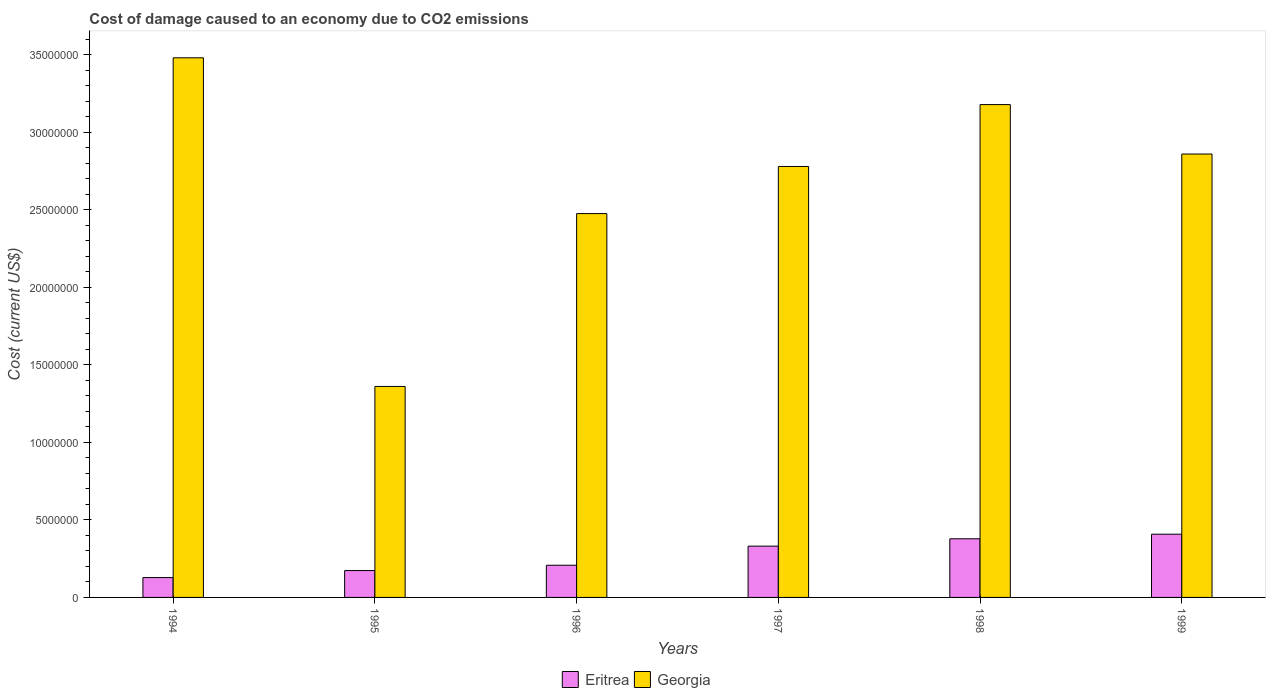How many different coloured bars are there?
Make the answer very short. 2. How many groups of bars are there?
Give a very brief answer. 6. Are the number of bars on each tick of the X-axis equal?
Your answer should be compact. Yes. How many bars are there on the 5th tick from the left?
Make the answer very short. 2. How many bars are there on the 6th tick from the right?
Give a very brief answer. 2. What is the label of the 1st group of bars from the left?
Keep it short and to the point. 1994. What is the cost of damage caused due to CO2 emissisons in Georgia in 1995?
Offer a terse response. 1.36e+07. Across all years, what is the maximum cost of damage caused due to CO2 emissisons in Georgia?
Offer a terse response. 3.48e+07. Across all years, what is the minimum cost of damage caused due to CO2 emissisons in Eritrea?
Ensure brevity in your answer.  1.28e+06. In which year was the cost of damage caused due to CO2 emissisons in Georgia minimum?
Offer a very short reply. 1995. What is the total cost of damage caused due to CO2 emissisons in Georgia in the graph?
Your response must be concise. 1.61e+08. What is the difference between the cost of damage caused due to CO2 emissisons in Georgia in 1996 and that in 1999?
Make the answer very short. -3.84e+06. What is the difference between the cost of damage caused due to CO2 emissisons in Eritrea in 1996 and the cost of damage caused due to CO2 emissisons in Georgia in 1999?
Provide a short and direct response. -2.65e+07. What is the average cost of damage caused due to CO2 emissisons in Eritrea per year?
Make the answer very short. 2.71e+06. In the year 1996, what is the difference between the cost of damage caused due to CO2 emissisons in Georgia and cost of damage caused due to CO2 emissisons in Eritrea?
Give a very brief answer. 2.27e+07. What is the ratio of the cost of damage caused due to CO2 emissisons in Eritrea in 1994 to that in 1999?
Your answer should be very brief. 0.31. Is the difference between the cost of damage caused due to CO2 emissisons in Georgia in 1994 and 1996 greater than the difference between the cost of damage caused due to CO2 emissisons in Eritrea in 1994 and 1996?
Offer a very short reply. Yes. What is the difference between the highest and the second highest cost of damage caused due to CO2 emissisons in Eritrea?
Ensure brevity in your answer.  2.96e+05. What is the difference between the highest and the lowest cost of damage caused due to CO2 emissisons in Eritrea?
Offer a very short reply. 2.80e+06. What does the 1st bar from the left in 1997 represents?
Ensure brevity in your answer.  Eritrea. What does the 1st bar from the right in 1999 represents?
Provide a short and direct response. Georgia. How many years are there in the graph?
Offer a terse response. 6. What is the difference between two consecutive major ticks on the Y-axis?
Your answer should be compact. 5.00e+06. Are the values on the major ticks of Y-axis written in scientific E-notation?
Offer a very short reply. No. Does the graph contain any zero values?
Provide a succinct answer. No. Does the graph contain grids?
Offer a very short reply. No. What is the title of the graph?
Your answer should be compact. Cost of damage caused to an economy due to CO2 emissions. What is the label or title of the Y-axis?
Provide a short and direct response. Cost (current US$). What is the Cost (current US$) of Eritrea in 1994?
Give a very brief answer. 1.28e+06. What is the Cost (current US$) of Georgia in 1994?
Provide a succinct answer. 3.48e+07. What is the Cost (current US$) of Eritrea in 1995?
Make the answer very short. 1.73e+06. What is the Cost (current US$) in Georgia in 1995?
Ensure brevity in your answer.  1.36e+07. What is the Cost (current US$) in Eritrea in 1996?
Provide a short and direct response. 2.08e+06. What is the Cost (current US$) of Georgia in 1996?
Make the answer very short. 2.48e+07. What is the Cost (current US$) of Eritrea in 1997?
Your response must be concise. 3.31e+06. What is the Cost (current US$) in Georgia in 1997?
Offer a terse response. 2.78e+07. What is the Cost (current US$) in Eritrea in 1998?
Your answer should be compact. 3.78e+06. What is the Cost (current US$) in Georgia in 1998?
Offer a very short reply. 3.18e+07. What is the Cost (current US$) in Eritrea in 1999?
Provide a short and direct response. 4.08e+06. What is the Cost (current US$) of Georgia in 1999?
Your response must be concise. 2.86e+07. Across all years, what is the maximum Cost (current US$) of Eritrea?
Ensure brevity in your answer.  4.08e+06. Across all years, what is the maximum Cost (current US$) of Georgia?
Offer a terse response. 3.48e+07. Across all years, what is the minimum Cost (current US$) in Eritrea?
Ensure brevity in your answer.  1.28e+06. Across all years, what is the minimum Cost (current US$) in Georgia?
Keep it short and to the point. 1.36e+07. What is the total Cost (current US$) of Eritrea in the graph?
Provide a succinct answer. 1.63e+07. What is the total Cost (current US$) of Georgia in the graph?
Provide a succinct answer. 1.61e+08. What is the difference between the Cost (current US$) of Eritrea in 1994 and that in 1995?
Keep it short and to the point. -4.54e+05. What is the difference between the Cost (current US$) of Georgia in 1994 and that in 1995?
Provide a succinct answer. 2.12e+07. What is the difference between the Cost (current US$) of Eritrea in 1994 and that in 1996?
Give a very brief answer. -7.96e+05. What is the difference between the Cost (current US$) in Georgia in 1994 and that in 1996?
Ensure brevity in your answer.  1.00e+07. What is the difference between the Cost (current US$) of Eritrea in 1994 and that in 1997?
Keep it short and to the point. -2.03e+06. What is the difference between the Cost (current US$) of Georgia in 1994 and that in 1997?
Ensure brevity in your answer.  7.01e+06. What is the difference between the Cost (current US$) in Eritrea in 1994 and that in 1998?
Give a very brief answer. -2.50e+06. What is the difference between the Cost (current US$) of Georgia in 1994 and that in 1998?
Provide a succinct answer. 3.02e+06. What is the difference between the Cost (current US$) of Eritrea in 1994 and that in 1999?
Provide a short and direct response. -2.80e+06. What is the difference between the Cost (current US$) in Georgia in 1994 and that in 1999?
Offer a very short reply. 6.21e+06. What is the difference between the Cost (current US$) in Eritrea in 1995 and that in 1996?
Provide a succinct answer. -3.43e+05. What is the difference between the Cost (current US$) in Georgia in 1995 and that in 1996?
Offer a terse response. -1.11e+07. What is the difference between the Cost (current US$) of Eritrea in 1995 and that in 1997?
Make the answer very short. -1.57e+06. What is the difference between the Cost (current US$) in Georgia in 1995 and that in 1997?
Give a very brief answer. -1.42e+07. What is the difference between the Cost (current US$) in Eritrea in 1995 and that in 1998?
Your answer should be compact. -2.05e+06. What is the difference between the Cost (current US$) in Georgia in 1995 and that in 1998?
Offer a terse response. -1.82e+07. What is the difference between the Cost (current US$) in Eritrea in 1995 and that in 1999?
Give a very brief answer. -2.35e+06. What is the difference between the Cost (current US$) of Georgia in 1995 and that in 1999?
Make the answer very short. -1.50e+07. What is the difference between the Cost (current US$) in Eritrea in 1996 and that in 1997?
Provide a short and direct response. -1.23e+06. What is the difference between the Cost (current US$) of Georgia in 1996 and that in 1997?
Ensure brevity in your answer.  -3.04e+06. What is the difference between the Cost (current US$) in Eritrea in 1996 and that in 1998?
Your answer should be very brief. -1.71e+06. What is the difference between the Cost (current US$) in Georgia in 1996 and that in 1998?
Your answer should be compact. -7.03e+06. What is the difference between the Cost (current US$) of Eritrea in 1996 and that in 1999?
Keep it short and to the point. -2.00e+06. What is the difference between the Cost (current US$) in Georgia in 1996 and that in 1999?
Provide a short and direct response. -3.84e+06. What is the difference between the Cost (current US$) in Eritrea in 1997 and that in 1998?
Provide a succinct answer. -4.75e+05. What is the difference between the Cost (current US$) in Georgia in 1997 and that in 1998?
Provide a short and direct response. -3.99e+06. What is the difference between the Cost (current US$) in Eritrea in 1997 and that in 1999?
Your response must be concise. -7.71e+05. What is the difference between the Cost (current US$) in Georgia in 1997 and that in 1999?
Make the answer very short. -8.03e+05. What is the difference between the Cost (current US$) in Eritrea in 1998 and that in 1999?
Keep it short and to the point. -2.96e+05. What is the difference between the Cost (current US$) of Georgia in 1998 and that in 1999?
Ensure brevity in your answer.  3.19e+06. What is the difference between the Cost (current US$) of Eritrea in 1994 and the Cost (current US$) of Georgia in 1995?
Your answer should be compact. -1.23e+07. What is the difference between the Cost (current US$) of Eritrea in 1994 and the Cost (current US$) of Georgia in 1996?
Give a very brief answer. -2.35e+07. What is the difference between the Cost (current US$) in Eritrea in 1994 and the Cost (current US$) in Georgia in 1997?
Give a very brief answer. -2.65e+07. What is the difference between the Cost (current US$) of Eritrea in 1994 and the Cost (current US$) of Georgia in 1998?
Your answer should be compact. -3.05e+07. What is the difference between the Cost (current US$) of Eritrea in 1994 and the Cost (current US$) of Georgia in 1999?
Give a very brief answer. -2.73e+07. What is the difference between the Cost (current US$) of Eritrea in 1995 and the Cost (current US$) of Georgia in 1996?
Provide a short and direct response. -2.30e+07. What is the difference between the Cost (current US$) of Eritrea in 1995 and the Cost (current US$) of Georgia in 1997?
Provide a succinct answer. -2.61e+07. What is the difference between the Cost (current US$) in Eritrea in 1995 and the Cost (current US$) in Georgia in 1998?
Your response must be concise. -3.01e+07. What is the difference between the Cost (current US$) in Eritrea in 1995 and the Cost (current US$) in Georgia in 1999?
Provide a short and direct response. -2.69e+07. What is the difference between the Cost (current US$) of Eritrea in 1996 and the Cost (current US$) of Georgia in 1997?
Your answer should be compact. -2.57e+07. What is the difference between the Cost (current US$) of Eritrea in 1996 and the Cost (current US$) of Georgia in 1998?
Provide a succinct answer. -2.97e+07. What is the difference between the Cost (current US$) of Eritrea in 1996 and the Cost (current US$) of Georgia in 1999?
Give a very brief answer. -2.65e+07. What is the difference between the Cost (current US$) in Eritrea in 1997 and the Cost (current US$) in Georgia in 1998?
Your response must be concise. -2.85e+07. What is the difference between the Cost (current US$) of Eritrea in 1997 and the Cost (current US$) of Georgia in 1999?
Your response must be concise. -2.53e+07. What is the difference between the Cost (current US$) of Eritrea in 1998 and the Cost (current US$) of Georgia in 1999?
Your answer should be compact. -2.48e+07. What is the average Cost (current US$) of Eritrea per year?
Your answer should be very brief. 2.71e+06. What is the average Cost (current US$) of Georgia per year?
Keep it short and to the point. 2.69e+07. In the year 1994, what is the difference between the Cost (current US$) in Eritrea and Cost (current US$) in Georgia?
Offer a very short reply. -3.35e+07. In the year 1995, what is the difference between the Cost (current US$) in Eritrea and Cost (current US$) in Georgia?
Offer a terse response. -1.19e+07. In the year 1996, what is the difference between the Cost (current US$) in Eritrea and Cost (current US$) in Georgia?
Your response must be concise. -2.27e+07. In the year 1997, what is the difference between the Cost (current US$) in Eritrea and Cost (current US$) in Georgia?
Keep it short and to the point. -2.45e+07. In the year 1998, what is the difference between the Cost (current US$) of Eritrea and Cost (current US$) of Georgia?
Your answer should be very brief. -2.80e+07. In the year 1999, what is the difference between the Cost (current US$) of Eritrea and Cost (current US$) of Georgia?
Offer a terse response. -2.45e+07. What is the ratio of the Cost (current US$) of Eritrea in 1994 to that in 1995?
Provide a succinct answer. 0.74. What is the ratio of the Cost (current US$) of Georgia in 1994 to that in 1995?
Offer a terse response. 2.56. What is the ratio of the Cost (current US$) of Eritrea in 1994 to that in 1996?
Give a very brief answer. 0.62. What is the ratio of the Cost (current US$) in Georgia in 1994 to that in 1996?
Your answer should be very brief. 1.41. What is the ratio of the Cost (current US$) in Eritrea in 1994 to that in 1997?
Give a very brief answer. 0.39. What is the ratio of the Cost (current US$) in Georgia in 1994 to that in 1997?
Your answer should be compact. 1.25. What is the ratio of the Cost (current US$) in Eritrea in 1994 to that in 1998?
Provide a succinct answer. 0.34. What is the ratio of the Cost (current US$) of Georgia in 1994 to that in 1998?
Provide a succinct answer. 1.09. What is the ratio of the Cost (current US$) in Eritrea in 1994 to that in 1999?
Provide a succinct answer. 0.31. What is the ratio of the Cost (current US$) in Georgia in 1994 to that in 1999?
Offer a terse response. 1.22. What is the ratio of the Cost (current US$) in Eritrea in 1995 to that in 1996?
Offer a terse response. 0.83. What is the ratio of the Cost (current US$) of Georgia in 1995 to that in 1996?
Provide a short and direct response. 0.55. What is the ratio of the Cost (current US$) of Eritrea in 1995 to that in 1997?
Give a very brief answer. 0.52. What is the ratio of the Cost (current US$) of Georgia in 1995 to that in 1997?
Ensure brevity in your answer.  0.49. What is the ratio of the Cost (current US$) of Eritrea in 1995 to that in 1998?
Offer a terse response. 0.46. What is the ratio of the Cost (current US$) of Georgia in 1995 to that in 1998?
Offer a very short reply. 0.43. What is the ratio of the Cost (current US$) of Eritrea in 1995 to that in 1999?
Make the answer very short. 0.42. What is the ratio of the Cost (current US$) of Georgia in 1995 to that in 1999?
Provide a short and direct response. 0.48. What is the ratio of the Cost (current US$) in Eritrea in 1996 to that in 1997?
Your response must be concise. 0.63. What is the ratio of the Cost (current US$) in Georgia in 1996 to that in 1997?
Your answer should be compact. 0.89. What is the ratio of the Cost (current US$) of Eritrea in 1996 to that in 1998?
Your answer should be compact. 0.55. What is the ratio of the Cost (current US$) of Georgia in 1996 to that in 1998?
Offer a very short reply. 0.78. What is the ratio of the Cost (current US$) of Eritrea in 1996 to that in 1999?
Your response must be concise. 0.51. What is the ratio of the Cost (current US$) of Georgia in 1996 to that in 1999?
Keep it short and to the point. 0.87. What is the ratio of the Cost (current US$) of Eritrea in 1997 to that in 1998?
Your response must be concise. 0.87. What is the ratio of the Cost (current US$) of Georgia in 1997 to that in 1998?
Keep it short and to the point. 0.87. What is the ratio of the Cost (current US$) of Eritrea in 1997 to that in 1999?
Your answer should be very brief. 0.81. What is the ratio of the Cost (current US$) of Georgia in 1997 to that in 1999?
Your answer should be very brief. 0.97. What is the ratio of the Cost (current US$) of Eritrea in 1998 to that in 1999?
Make the answer very short. 0.93. What is the ratio of the Cost (current US$) in Georgia in 1998 to that in 1999?
Offer a terse response. 1.11. What is the difference between the highest and the second highest Cost (current US$) in Eritrea?
Give a very brief answer. 2.96e+05. What is the difference between the highest and the second highest Cost (current US$) in Georgia?
Provide a succinct answer. 3.02e+06. What is the difference between the highest and the lowest Cost (current US$) in Eritrea?
Give a very brief answer. 2.80e+06. What is the difference between the highest and the lowest Cost (current US$) of Georgia?
Provide a short and direct response. 2.12e+07. 